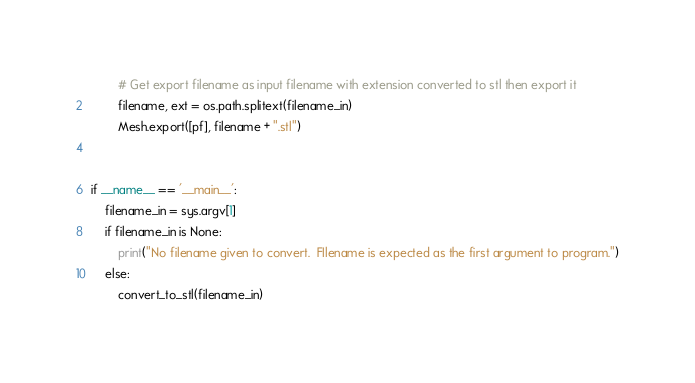Convert code to text. <code><loc_0><loc_0><loc_500><loc_500><_Python_>        # Get export filename as input filename with extension converted to stl then export it
        filename, ext = os.path.splitext(filename_in)
        Mesh.export([pf], filename + ".stl")


if __name__ == '__main__':
    filename_in = sys.argv[1]
    if filename_in is None:
        print("No filename given to convert.  FIlename is expected as the first argument to program.")
    else:
        convert_to_stl(filename_in)
</code> 